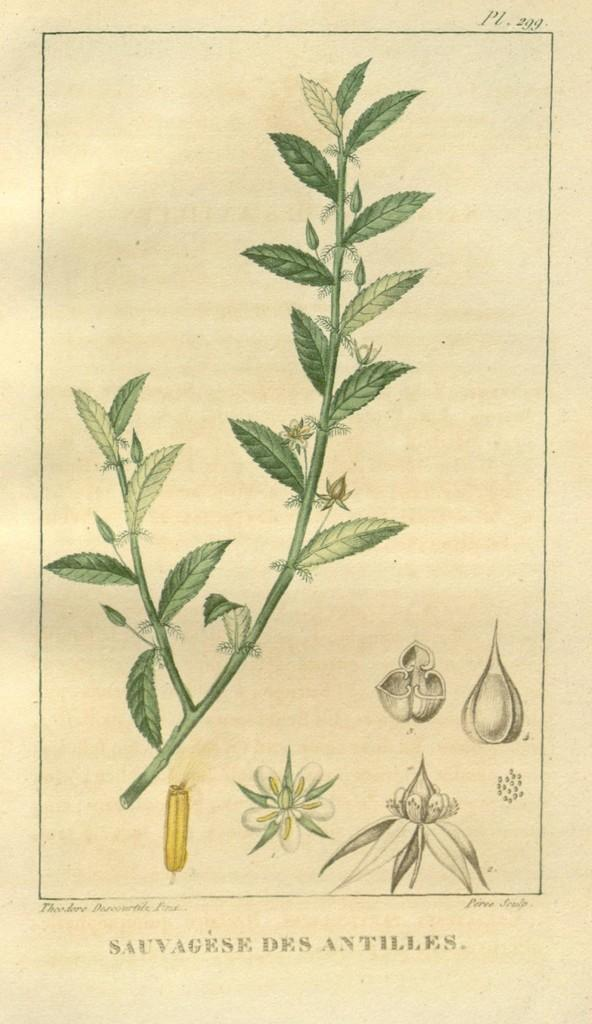What type of living organism is present in the image? There is a plant in the image. What is the color of the plant? The plant is green in color. Which parts of the plant can be seen in the image? There are parts of the plant visible in the image. What else is present in the image besides the plant? There is a paper with writing on it in the image. How many kittens are playing with the tub in the image? There are no kittens or tubs present in the image. What word is written on the paper in the image? The provided facts do not mention the specific word written on the paper, so we cannot answer that question. 